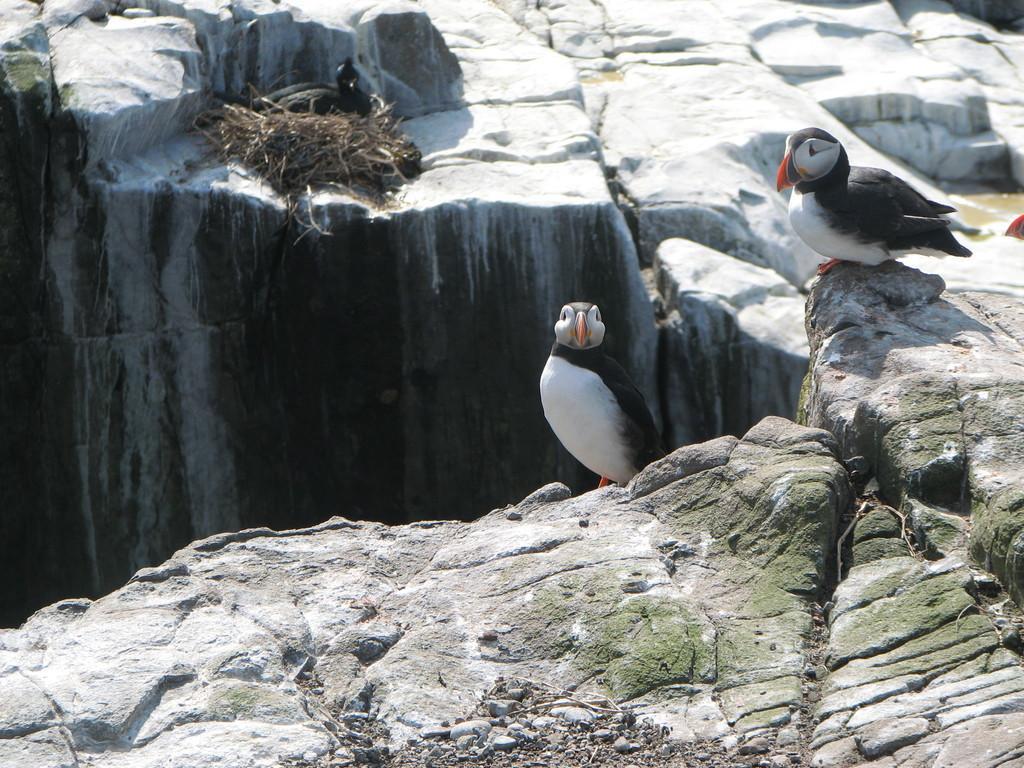Can you describe this image briefly? This image consists of birds. At the bottom, we can see the rocks. And a black color bird is sitting in the next. 